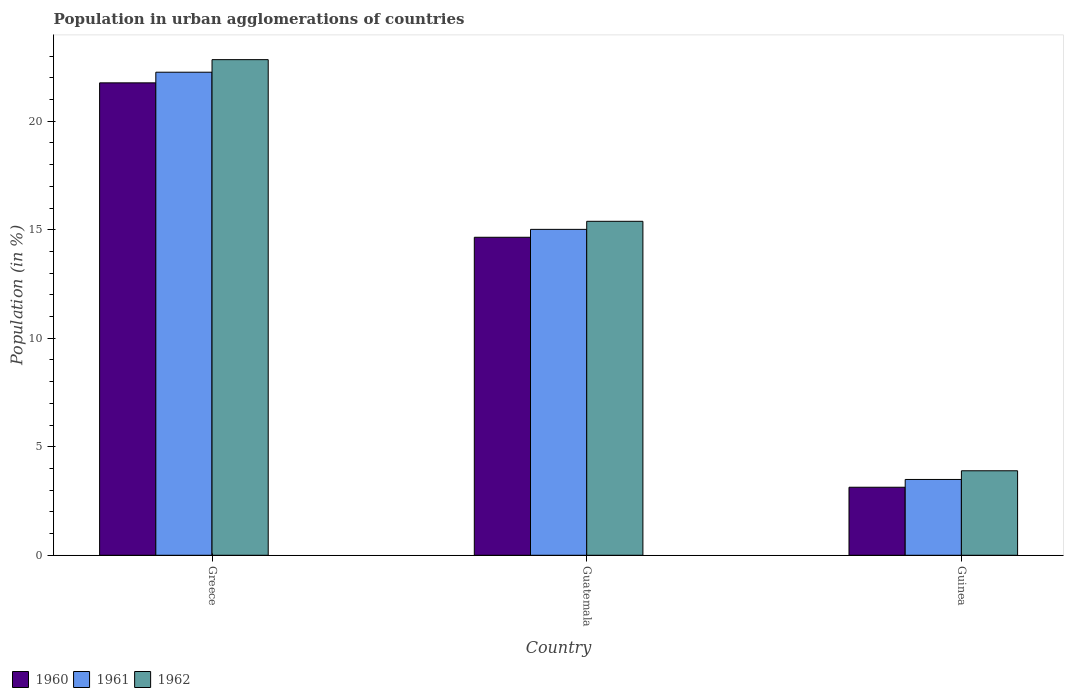Are the number of bars on each tick of the X-axis equal?
Your response must be concise. Yes. What is the label of the 3rd group of bars from the left?
Keep it short and to the point. Guinea. In how many cases, is the number of bars for a given country not equal to the number of legend labels?
Your response must be concise. 0. What is the percentage of population in urban agglomerations in 1962 in Greece?
Offer a very short reply. 22.84. Across all countries, what is the maximum percentage of population in urban agglomerations in 1960?
Your response must be concise. 21.77. Across all countries, what is the minimum percentage of population in urban agglomerations in 1960?
Provide a succinct answer. 3.14. In which country was the percentage of population in urban agglomerations in 1962 minimum?
Keep it short and to the point. Guinea. What is the total percentage of population in urban agglomerations in 1960 in the graph?
Your response must be concise. 39.56. What is the difference between the percentage of population in urban agglomerations in 1960 in Greece and that in Guinea?
Make the answer very short. 18.63. What is the difference between the percentage of population in urban agglomerations in 1961 in Greece and the percentage of population in urban agglomerations in 1962 in Guatemala?
Give a very brief answer. 6.87. What is the average percentage of population in urban agglomerations in 1960 per country?
Your answer should be very brief. 13.19. What is the difference between the percentage of population in urban agglomerations of/in 1960 and percentage of population in urban agglomerations of/in 1962 in Greece?
Provide a succinct answer. -1.07. What is the ratio of the percentage of population in urban agglomerations in 1962 in Greece to that in Guatemala?
Provide a short and direct response. 1.48. Is the percentage of population in urban agglomerations in 1960 in Greece less than that in Guatemala?
Give a very brief answer. No. Is the difference between the percentage of population in urban agglomerations in 1960 in Guatemala and Guinea greater than the difference between the percentage of population in urban agglomerations in 1962 in Guatemala and Guinea?
Keep it short and to the point. Yes. What is the difference between the highest and the second highest percentage of population in urban agglomerations in 1962?
Provide a succinct answer. -18.94. What is the difference between the highest and the lowest percentage of population in urban agglomerations in 1962?
Ensure brevity in your answer.  18.94. What does the 2nd bar from the left in Guatemala represents?
Provide a succinct answer. 1961. What does the 2nd bar from the right in Guinea represents?
Give a very brief answer. 1961. How many bars are there?
Ensure brevity in your answer.  9. Are the values on the major ticks of Y-axis written in scientific E-notation?
Offer a terse response. No. Does the graph contain grids?
Offer a terse response. No. How many legend labels are there?
Your answer should be compact. 3. How are the legend labels stacked?
Offer a very short reply. Horizontal. What is the title of the graph?
Ensure brevity in your answer.  Population in urban agglomerations of countries. What is the label or title of the Y-axis?
Make the answer very short. Population (in %). What is the Population (in %) in 1960 in Greece?
Your answer should be very brief. 21.77. What is the Population (in %) in 1961 in Greece?
Your answer should be compact. 22.26. What is the Population (in %) of 1962 in Greece?
Keep it short and to the point. 22.84. What is the Population (in %) in 1960 in Guatemala?
Provide a succinct answer. 14.65. What is the Population (in %) of 1961 in Guatemala?
Ensure brevity in your answer.  15.02. What is the Population (in %) in 1962 in Guatemala?
Provide a succinct answer. 15.39. What is the Population (in %) of 1960 in Guinea?
Ensure brevity in your answer.  3.14. What is the Population (in %) in 1961 in Guinea?
Keep it short and to the point. 3.49. What is the Population (in %) of 1962 in Guinea?
Keep it short and to the point. 3.89. Across all countries, what is the maximum Population (in %) of 1960?
Offer a terse response. 21.77. Across all countries, what is the maximum Population (in %) of 1961?
Your answer should be very brief. 22.26. Across all countries, what is the maximum Population (in %) of 1962?
Keep it short and to the point. 22.84. Across all countries, what is the minimum Population (in %) of 1960?
Your answer should be compact. 3.14. Across all countries, what is the minimum Population (in %) in 1961?
Provide a succinct answer. 3.49. Across all countries, what is the minimum Population (in %) in 1962?
Give a very brief answer. 3.89. What is the total Population (in %) of 1960 in the graph?
Your answer should be compact. 39.56. What is the total Population (in %) in 1961 in the graph?
Give a very brief answer. 40.77. What is the total Population (in %) in 1962 in the graph?
Offer a terse response. 42.12. What is the difference between the Population (in %) in 1960 in Greece and that in Guatemala?
Give a very brief answer. 7.12. What is the difference between the Population (in %) in 1961 in Greece and that in Guatemala?
Ensure brevity in your answer.  7.24. What is the difference between the Population (in %) of 1962 in Greece and that in Guatemala?
Give a very brief answer. 7.45. What is the difference between the Population (in %) of 1960 in Greece and that in Guinea?
Provide a short and direct response. 18.63. What is the difference between the Population (in %) in 1961 in Greece and that in Guinea?
Ensure brevity in your answer.  18.77. What is the difference between the Population (in %) in 1962 in Greece and that in Guinea?
Ensure brevity in your answer.  18.94. What is the difference between the Population (in %) of 1960 in Guatemala and that in Guinea?
Give a very brief answer. 11.52. What is the difference between the Population (in %) in 1961 in Guatemala and that in Guinea?
Offer a terse response. 11.52. What is the difference between the Population (in %) of 1962 in Guatemala and that in Guinea?
Offer a terse response. 11.49. What is the difference between the Population (in %) in 1960 in Greece and the Population (in %) in 1961 in Guatemala?
Make the answer very short. 6.75. What is the difference between the Population (in %) of 1960 in Greece and the Population (in %) of 1962 in Guatemala?
Provide a succinct answer. 6.38. What is the difference between the Population (in %) in 1961 in Greece and the Population (in %) in 1962 in Guatemala?
Make the answer very short. 6.87. What is the difference between the Population (in %) of 1960 in Greece and the Population (in %) of 1961 in Guinea?
Provide a short and direct response. 18.27. What is the difference between the Population (in %) of 1960 in Greece and the Population (in %) of 1962 in Guinea?
Make the answer very short. 17.87. What is the difference between the Population (in %) in 1961 in Greece and the Population (in %) in 1962 in Guinea?
Your answer should be very brief. 18.37. What is the difference between the Population (in %) of 1960 in Guatemala and the Population (in %) of 1961 in Guinea?
Provide a succinct answer. 11.16. What is the difference between the Population (in %) of 1960 in Guatemala and the Population (in %) of 1962 in Guinea?
Your answer should be very brief. 10.76. What is the difference between the Population (in %) in 1961 in Guatemala and the Population (in %) in 1962 in Guinea?
Give a very brief answer. 11.12. What is the average Population (in %) in 1960 per country?
Make the answer very short. 13.19. What is the average Population (in %) of 1961 per country?
Offer a very short reply. 13.59. What is the average Population (in %) in 1962 per country?
Offer a very short reply. 14.04. What is the difference between the Population (in %) in 1960 and Population (in %) in 1961 in Greece?
Offer a very short reply. -0.49. What is the difference between the Population (in %) in 1960 and Population (in %) in 1962 in Greece?
Offer a very short reply. -1.07. What is the difference between the Population (in %) of 1961 and Population (in %) of 1962 in Greece?
Ensure brevity in your answer.  -0.58. What is the difference between the Population (in %) of 1960 and Population (in %) of 1961 in Guatemala?
Ensure brevity in your answer.  -0.36. What is the difference between the Population (in %) in 1960 and Population (in %) in 1962 in Guatemala?
Provide a short and direct response. -0.74. What is the difference between the Population (in %) of 1961 and Population (in %) of 1962 in Guatemala?
Make the answer very short. -0.37. What is the difference between the Population (in %) of 1960 and Population (in %) of 1961 in Guinea?
Provide a succinct answer. -0.36. What is the difference between the Population (in %) in 1960 and Population (in %) in 1962 in Guinea?
Your response must be concise. -0.76. What is the difference between the Population (in %) of 1961 and Population (in %) of 1962 in Guinea?
Your response must be concise. -0.4. What is the ratio of the Population (in %) in 1960 in Greece to that in Guatemala?
Give a very brief answer. 1.49. What is the ratio of the Population (in %) in 1961 in Greece to that in Guatemala?
Ensure brevity in your answer.  1.48. What is the ratio of the Population (in %) in 1962 in Greece to that in Guatemala?
Offer a very short reply. 1.48. What is the ratio of the Population (in %) in 1960 in Greece to that in Guinea?
Make the answer very short. 6.94. What is the ratio of the Population (in %) in 1961 in Greece to that in Guinea?
Your answer should be compact. 6.37. What is the ratio of the Population (in %) of 1962 in Greece to that in Guinea?
Provide a short and direct response. 5.87. What is the ratio of the Population (in %) in 1960 in Guatemala to that in Guinea?
Offer a terse response. 4.67. What is the ratio of the Population (in %) in 1961 in Guatemala to that in Guinea?
Offer a terse response. 4.3. What is the ratio of the Population (in %) in 1962 in Guatemala to that in Guinea?
Your answer should be very brief. 3.95. What is the difference between the highest and the second highest Population (in %) in 1960?
Your answer should be compact. 7.12. What is the difference between the highest and the second highest Population (in %) of 1961?
Offer a very short reply. 7.24. What is the difference between the highest and the second highest Population (in %) of 1962?
Offer a terse response. 7.45. What is the difference between the highest and the lowest Population (in %) of 1960?
Make the answer very short. 18.63. What is the difference between the highest and the lowest Population (in %) of 1961?
Your answer should be very brief. 18.77. What is the difference between the highest and the lowest Population (in %) in 1962?
Offer a terse response. 18.94. 